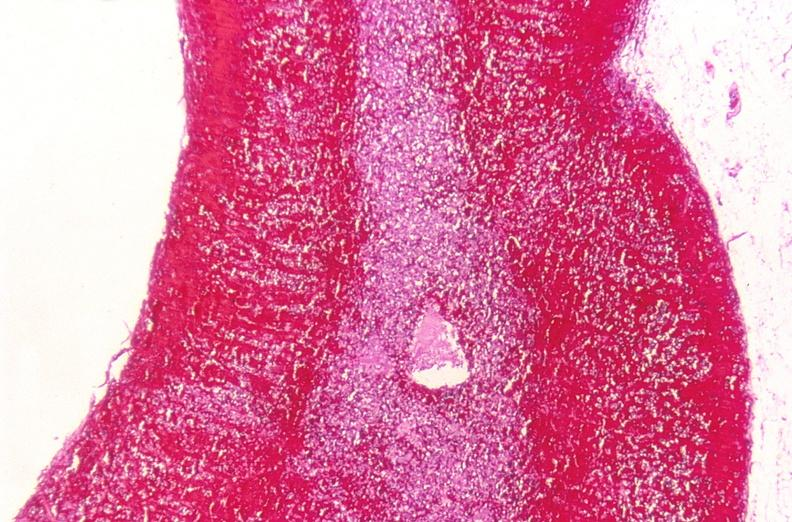what is present?
Answer the question using a single word or phrase. Endocrine 